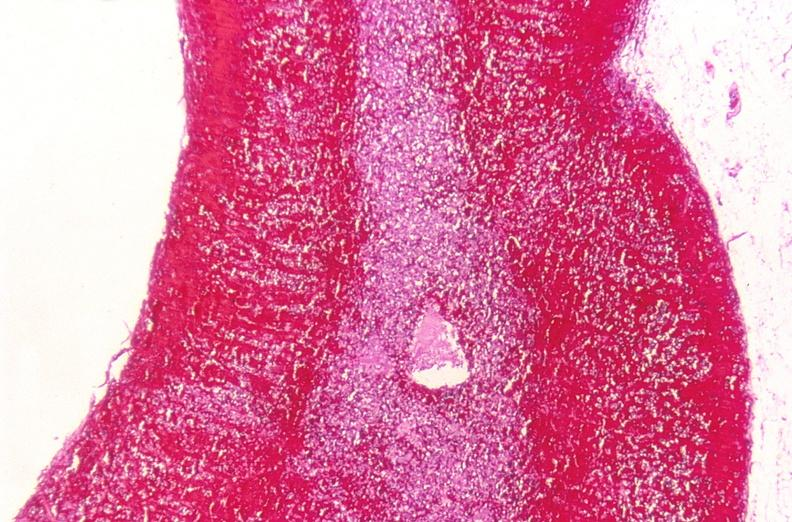what is present?
Answer the question using a single word or phrase. Endocrine 